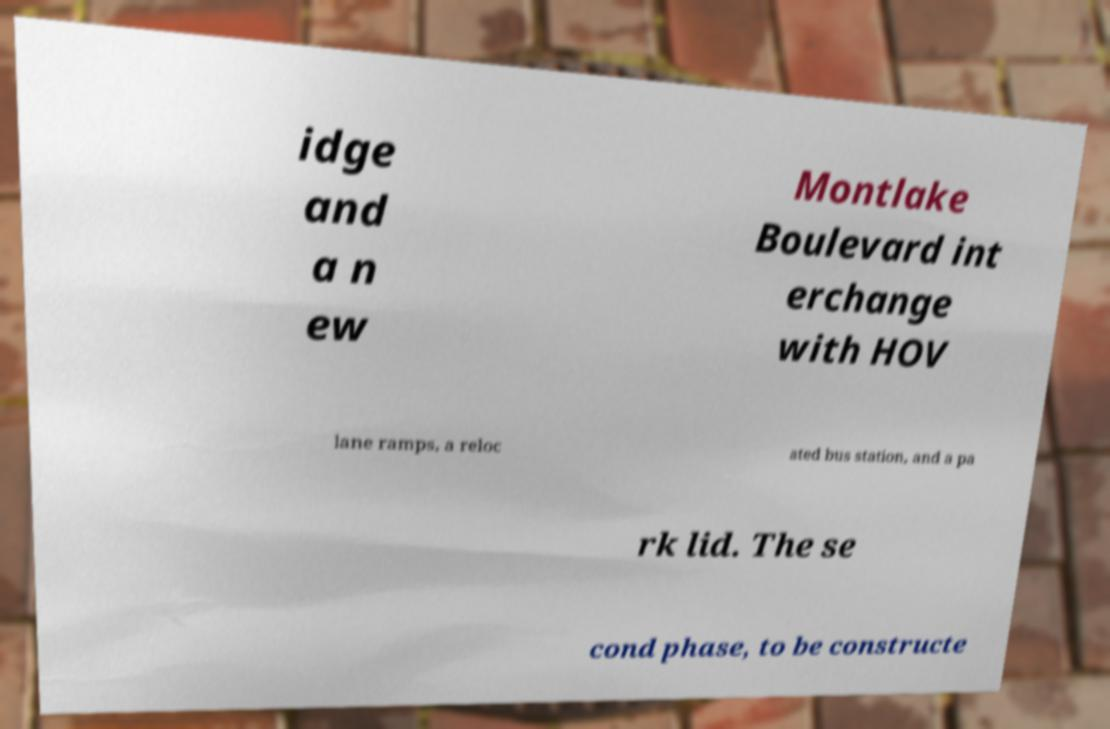Can you accurately transcribe the text from the provided image for me? idge and a n ew Montlake Boulevard int erchange with HOV lane ramps, a reloc ated bus station, and a pa rk lid. The se cond phase, to be constructe 